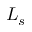Convert formula to latex. <formula><loc_0><loc_0><loc_500><loc_500>L _ { s }</formula> 